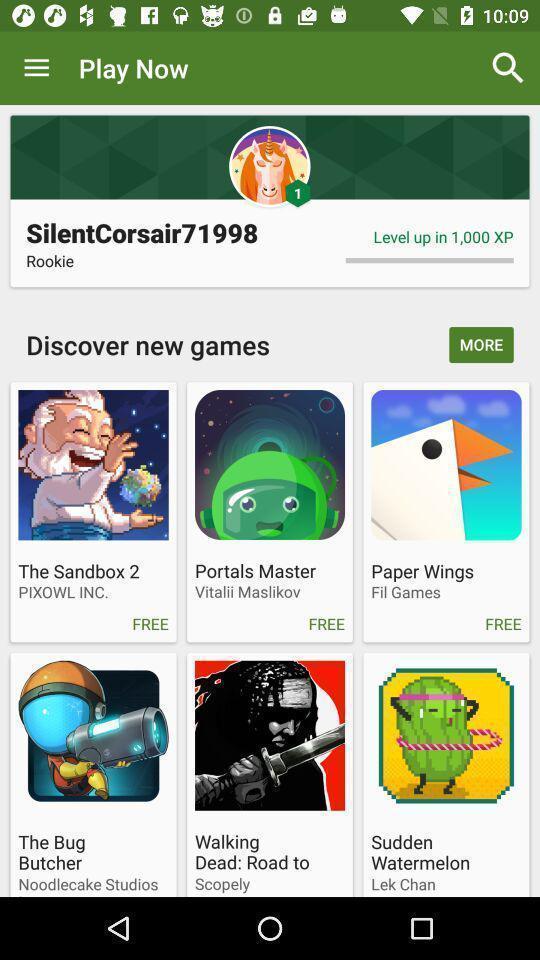What is the overall content of this screenshot? Page showing different games. 